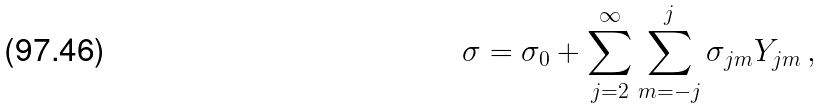<formula> <loc_0><loc_0><loc_500><loc_500>\sigma = \sigma _ { 0 } + \sum _ { j = 2 } ^ { \infty } \sum _ { m = - j } ^ { j } \sigma _ { j m } Y _ { j m } \, ,</formula> 